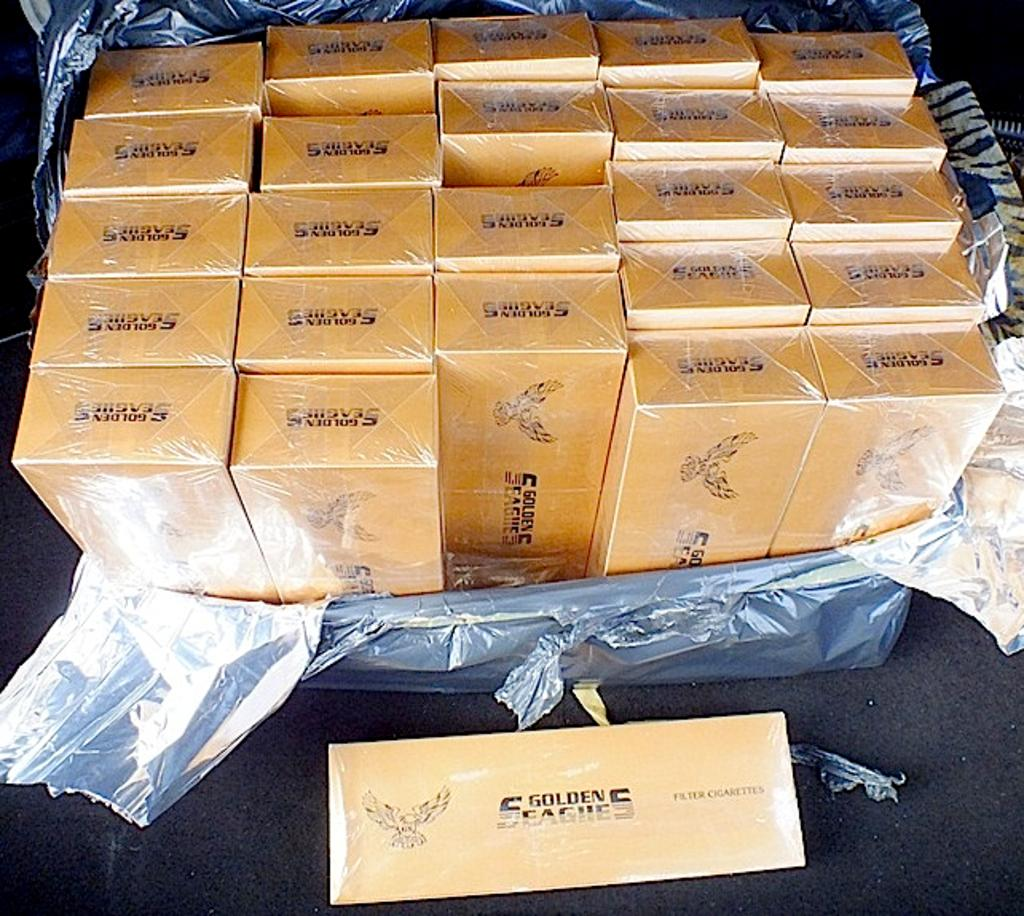What is located at the bottom of the image? There is a table at the bottom of the image. What is the main subject in the middle of the image? There are many boxes in the middle of the image. How are the boxes protected in the image? The boxes are covered with a polythene sheet. What is on the table in the image? There is another box on the table. Can you see any passengers walking on the street in the image? There is no reference to passengers or streets in the image; it features a table with boxes and a polythene sheet. 